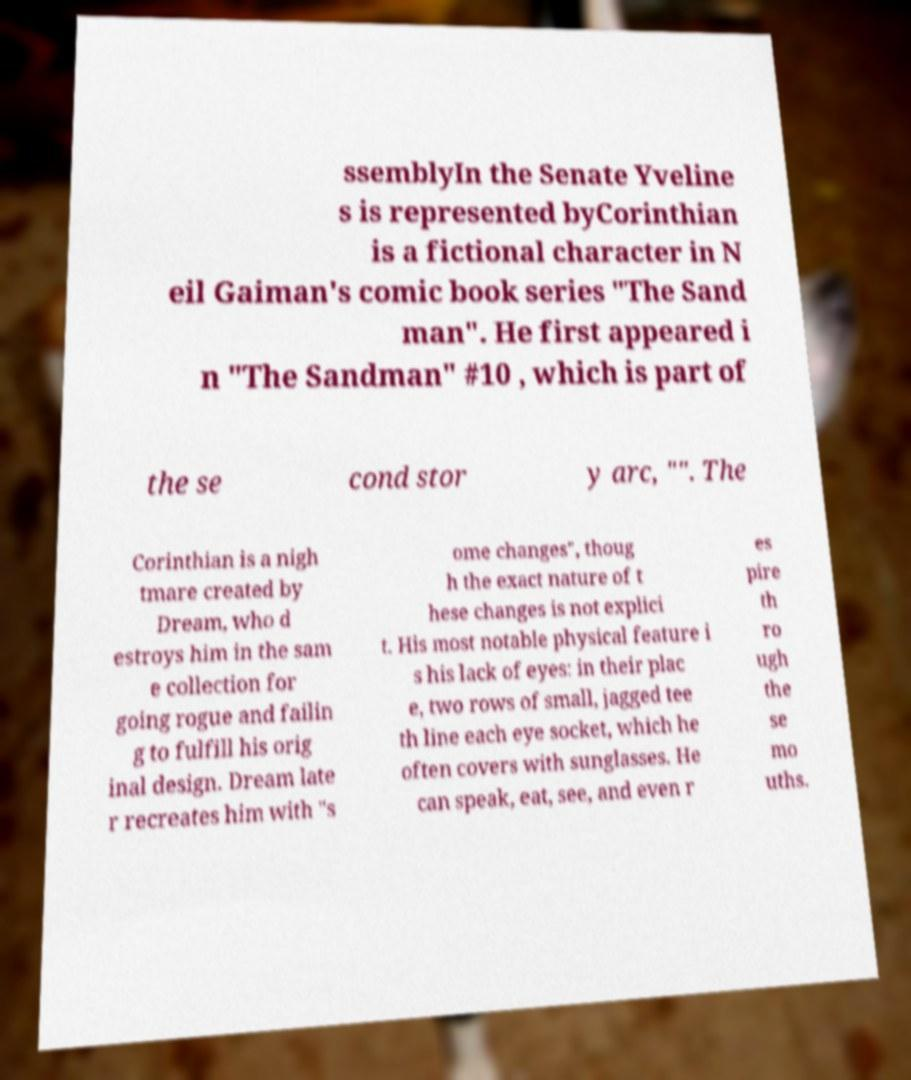Can you read and provide the text displayed in the image?This photo seems to have some interesting text. Can you extract and type it out for me? ssemblyIn the Senate Yveline s is represented byCorinthian is a fictional character in N eil Gaiman's comic book series "The Sand man". He first appeared i n "The Sandman" #10 , which is part of the se cond stor y arc, "". The Corinthian is a nigh tmare created by Dream, who d estroys him in the sam e collection for going rogue and failin g to fulfill his orig inal design. Dream late r recreates him with "s ome changes", thoug h the exact nature of t hese changes is not explici t. His most notable physical feature i s his lack of eyes: in their plac e, two rows of small, jagged tee th line each eye socket, which he often covers with sunglasses. He can speak, eat, see, and even r es pire th ro ugh the se mo uths. 